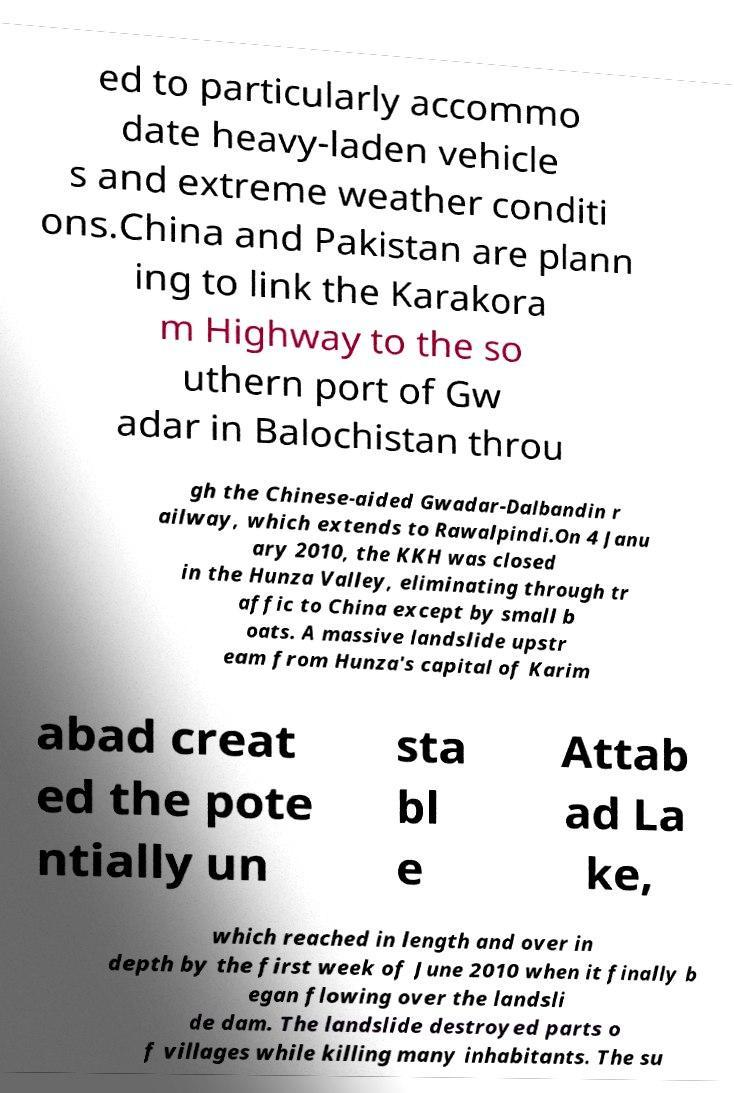Please identify and transcribe the text found in this image. ed to particularly accommo date heavy-laden vehicle s and extreme weather conditi ons.China and Pakistan are plann ing to link the Karakora m Highway to the so uthern port of Gw adar in Balochistan throu gh the Chinese-aided Gwadar-Dalbandin r ailway, which extends to Rawalpindi.On 4 Janu ary 2010, the KKH was closed in the Hunza Valley, eliminating through tr affic to China except by small b oats. A massive landslide upstr eam from Hunza's capital of Karim abad creat ed the pote ntially un sta bl e Attab ad La ke, which reached in length and over in depth by the first week of June 2010 when it finally b egan flowing over the landsli de dam. The landslide destroyed parts o f villages while killing many inhabitants. The su 